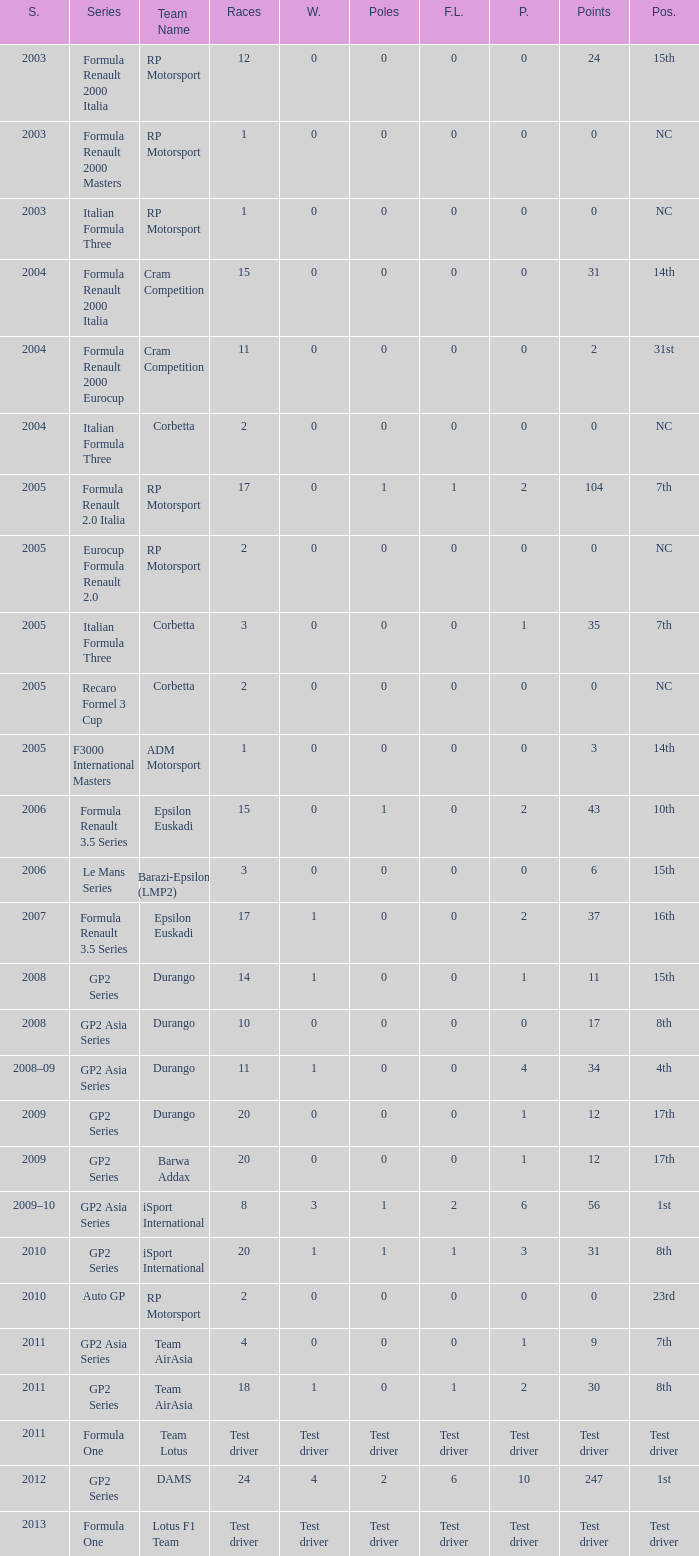What is the number of poles with 104 points? 1.0. 